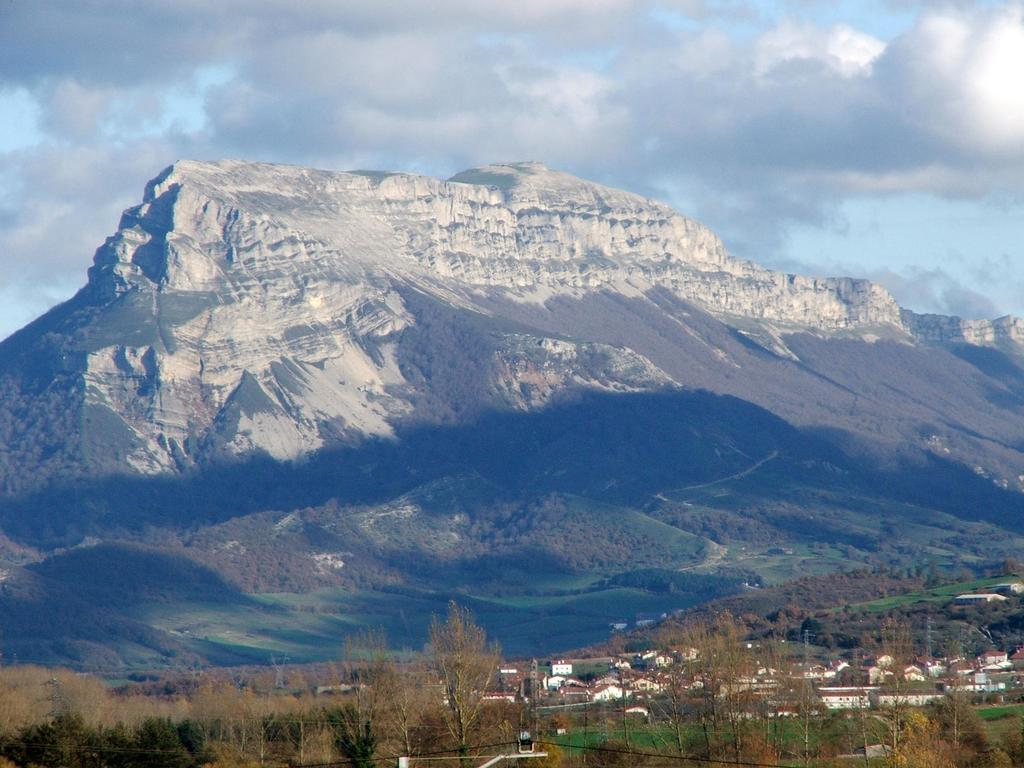What can be seen in the foreground of the image? There are trees and buildings in front of the image. What is visible in the background of the image? There are mountains in the background of the image. What is present in the sky in the image? There are clouds visible at the top of the image in the sky. How does the family turn and twist in the image? There is no family present in the image, so this question cannot be answered. 